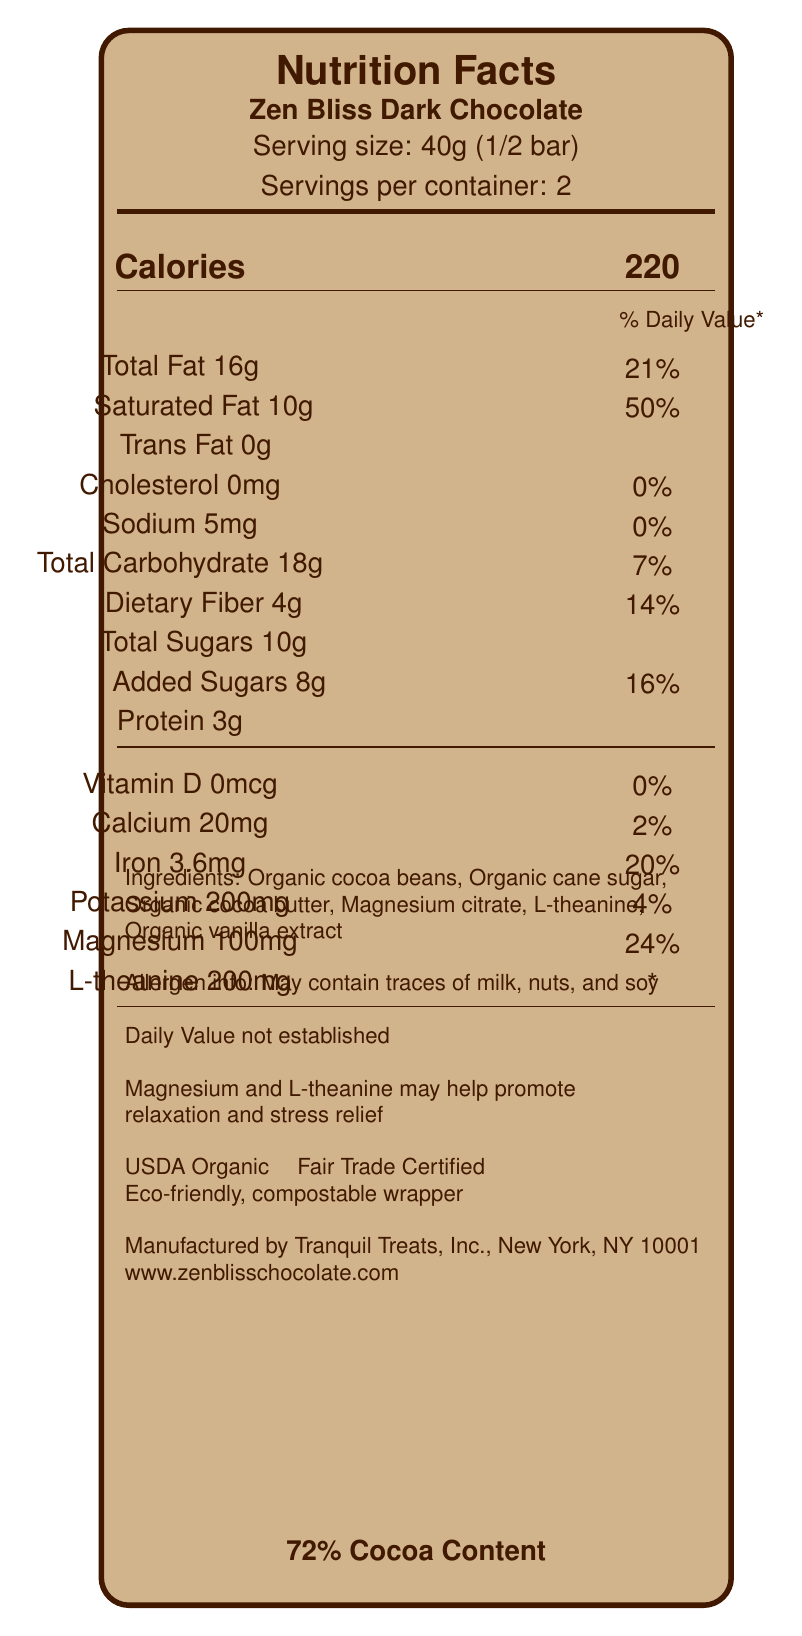What is the serving size of Zen Bliss Dark Chocolate? The serving size is explicitly listed as 40g (1/2 bar) on the nutrition label.
Answer: 40g (1/2 bar) How many calories are in one serving of Zen Bliss Dark Chocolate? The label states that one serving contains 220 calories.
Answer: 220 What is the total fat content per serving, and what percentage of the daily value does this represent? The label shows that the total fat content is 16g per serving, which is 21% of the daily value.
Answer: 16g, 21% What are the main ingredients in Zen Bliss Dark Chocolate? These ingredients are listed in the ingredients section of the label.
Answer: Organic cocoa beans, Organic cane sugar, Organic cocoa butter, Magnesium citrate, L-theanine, Organic vanilla extract Is the product USDA Organic certified? The label states that the product is USDA Organic certified.
Answer: Yes What is the daily value percentage for saturated fat per serving? A. 10% B. 21% C. 50% D. 24% The label indicates that the saturated fat per serving is 10g, which corresponds to 50% of the daily value.
Answer: C. 50% How much magnesium is in one serving of Zen Bliss Dark Chocolate? A. 20mg B. 100mg C. 200mg D. 150mg The label lists the magnesium content as 100mg per serving.
Answer: B. 100mg True or False: Zen Bliss Dark Chocolate contains no trans fat. The label clearly shows that the trans fat content is 0g per serving.
Answer: True Summarize the overall purpose and main features of Zen Bliss Dark Chocolate. The explanation consolidates multiple pieces of information: the product’s purpose (stress relief), features (calories, certifications), and additional benefits (eco-friendly packaging).
Answer: Zen Bliss Dark Chocolate is designed as a premium dark chocolate enriched with relaxation-promoting ingredients, including magnesium and L-theanine. It offers 220 calories per 40g serving and is USDA Organic certified and Fair Trade Certified. It features a 72% cocoa content and is packaged in an eco-friendly, compostable wrapper. What is the percentage of the daily value for iron in one serving? The nutrition label shows that one serving contains 3.6mg of iron, which is 20% of the daily value.
Answer: 20% Does Zen Bliss Dark Chocolate contain any cholesterol? The label shows that the cholesterol content per serving is 0mg.
Answer: No Which of the following allergens may be present in Zen Bliss Dark Chocolate? A. Milk B. Nuts C. Soy D. All of the above The allergen information warns that the product may contain traces of milk, nuts, and soy.
Answer: D. All of the above What is the cocoa content percentage in Zen Bliss Dark Chocolate? The bottom of the label clearly states that the cocoa content is 72%.
Answer: 72% How much protein is in one serving of Zen Bliss Dark Chocolate? The nutrition label lists the protein content as 3g per serving.
Answer: 3g Can the daily value of L-theanine be determined from this label? The daily value for L-theanine is marked as *, with a note stating that the daily value is not established.
Answer: No How is the packaging of Zen Bliss Dark Chocolate described? The label describes the packaging as eco-friendly and compostable.
Answer: Eco-friendly, compostable wrapper What is the website for more information on Zen Bliss Dark Chocolate? The label provides the website as www.zenblisschocolate.com for more information.
Answer: www.zenblisschocolate.com What is the company's name and address that manufactures Zen Bliss Dark Chocolate? The label mentions that Zen Bliss Dark Chocolate is manufactured by Tranquil Treats, Inc., based in New York, NY 10001.
Answer: Tranquil Treats, Inc., New York, NY 10001 